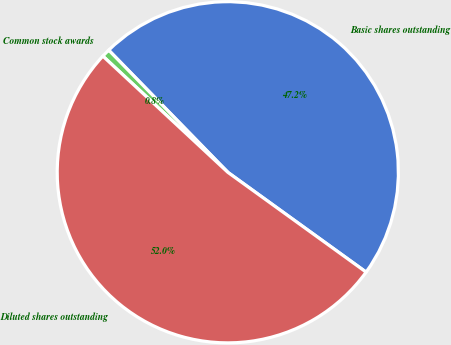Convert chart to OTSL. <chart><loc_0><loc_0><loc_500><loc_500><pie_chart><fcel>Basic shares outstanding<fcel>Common stock awards<fcel>Diluted shares outstanding<nl><fcel>47.25%<fcel>0.78%<fcel>51.97%<nl></chart> 